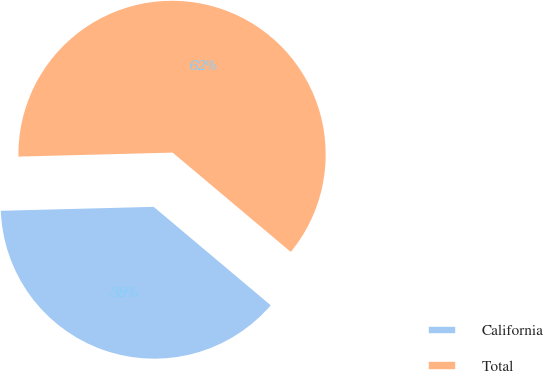Convert chart. <chart><loc_0><loc_0><loc_500><loc_500><pie_chart><fcel>California<fcel>Total<nl><fcel>38.46%<fcel>61.54%<nl></chart> 